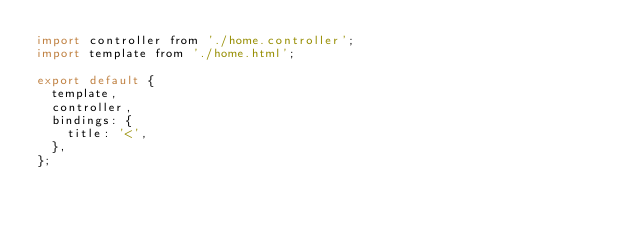Convert code to text. <code><loc_0><loc_0><loc_500><loc_500><_JavaScript_>import controller from './home.controller';
import template from './home.html';

export default {
  template,
  controller,
  bindings: {
    title: '<',
  },
};
</code> 